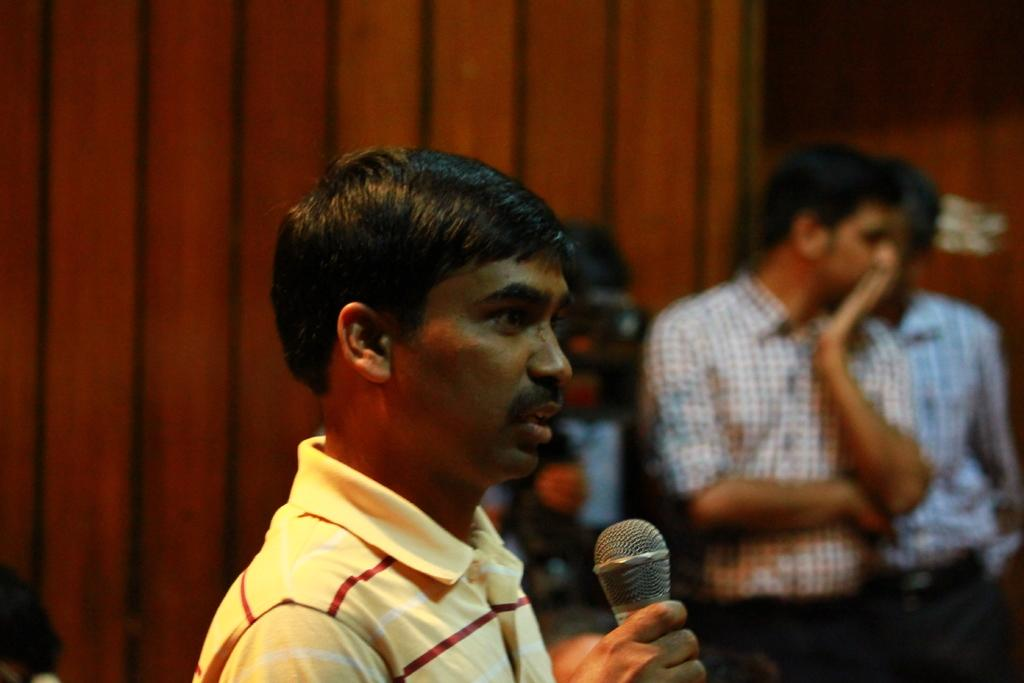What is the main subject of the image? The main subject of the image is a man. What is the man wearing? The man is wearing a yellow t-shirt. What is the man holding in the image? The man is holding a microphone. What is the man doing in the image? The man is talking. What can be seen in the background of the image? There are people, a curtain, and a wall in the background of the image. Can you tell me who won the argument between the man and the person in the background? There is no argument depicted in the image, so it is not possible to determine who won. What color are the man's eyes in the image? The color of the man's eyes is not mentioned in the provided facts, so it cannot be determined from the image. 